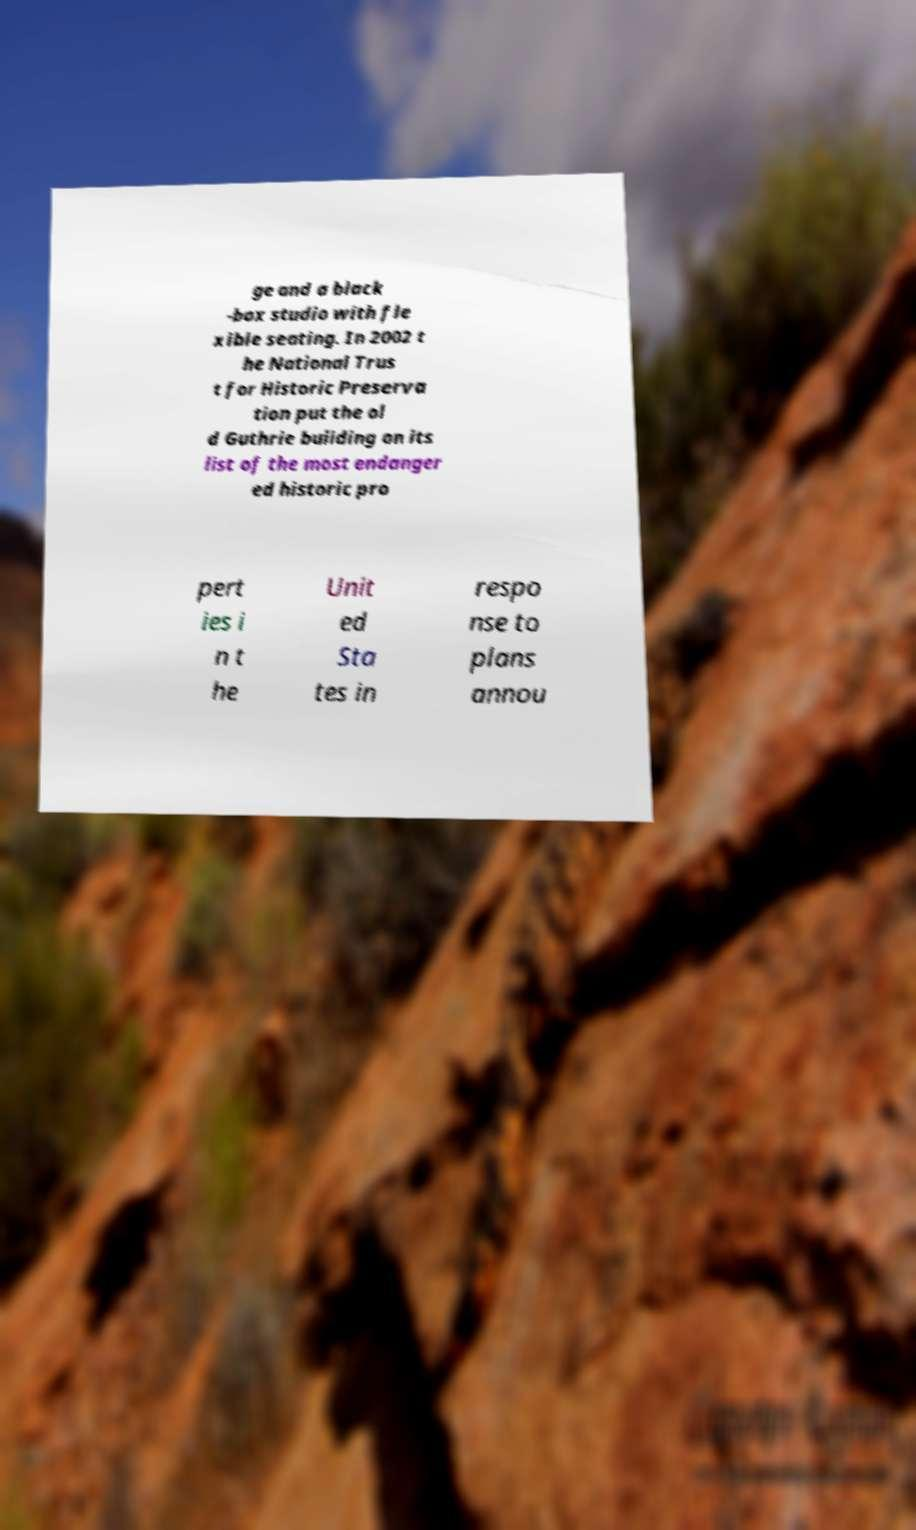Please read and relay the text visible in this image. What does it say? ge and a black -box studio with fle xible seating. In 2002 t he National Trus t for Historic Preserva tion put the ol d Guthrie building on its list of the most endanger ed historic pro pert ies i n t he Unit ed Sta tes in respo nse to plans annou 